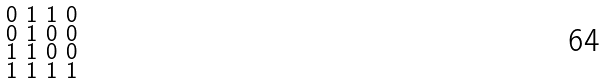Convert formula to latex. <formula><loc_0><loc_0><loc_500><loc_500>\begin{smallmatrix} 0 & 1 & 1 & 0 \\ 0 & 1 & 0 & 0 \\ 1 & 1 & 0 & 0 \\ 1 & 1 & 1 & 1 \\ \end{smallmatrix}</formula> 